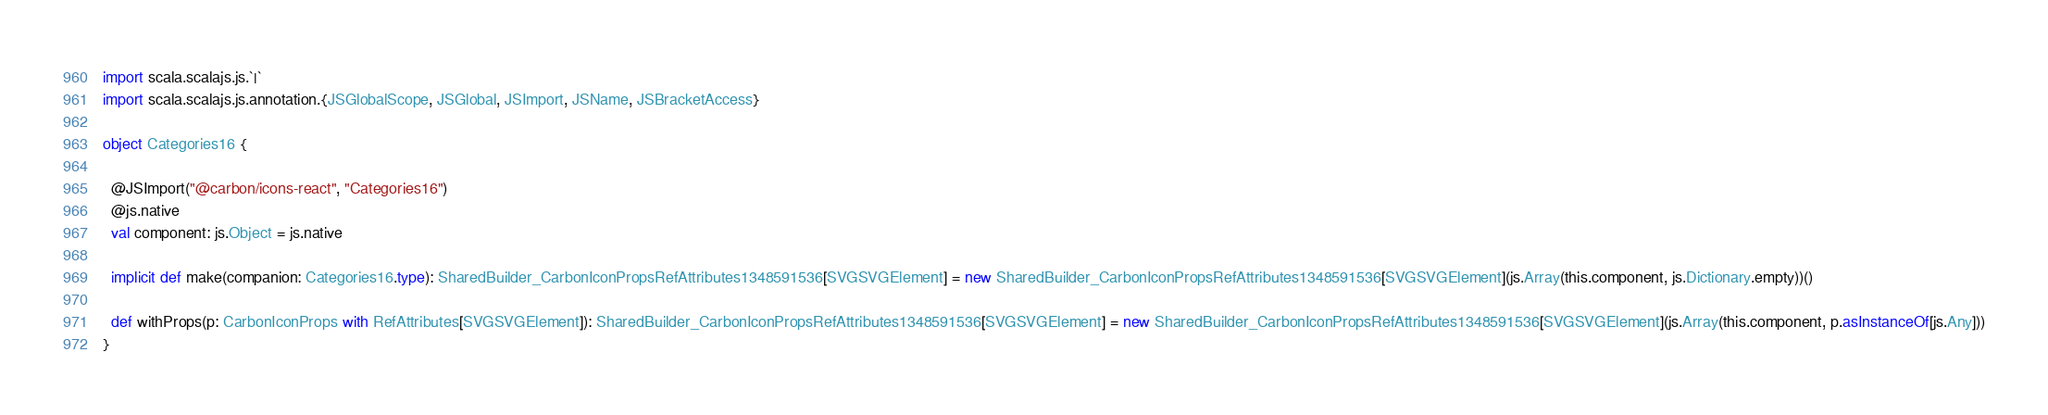Convert code to text. <code><loc_0><loc_0><loc_500><loc_500><_Scala_>import scala.scalajs.js.`|`
import scala.scalajs.js.annotation.{JSGlobalScope, JSGlobal, JSImport, JSName, JSBracketAccess}

object Categories16 {
  
  @JSImport("@carbon/icons-react", "Categories16")
  @js.native
  val component: js.Object = js.native
  
  implicit def make(companion: Categories16.type): SharedBuilder_CarbonIconPropsRefAttributes1348591536[SVGSVGElement] = new SharedBuilder_CarbonIconPropsRefAttributes1348591536[SVGSVGElement](js.Array(this.component, js.Dictionary.empty))()
  
  def withProps(p: CarbonIconProps with RefAttributes[SVGSVGElement]): SharedBuilder_CarbonIconPropsRefAttributes1348591536[SVGSVGElement] = new SharedBuilder_CarbonIconPropsRefAttributes1348591536[SVGSVGElement](js.Array(this.component, p.asInstanceOf[js.Any]))
}
</code> 